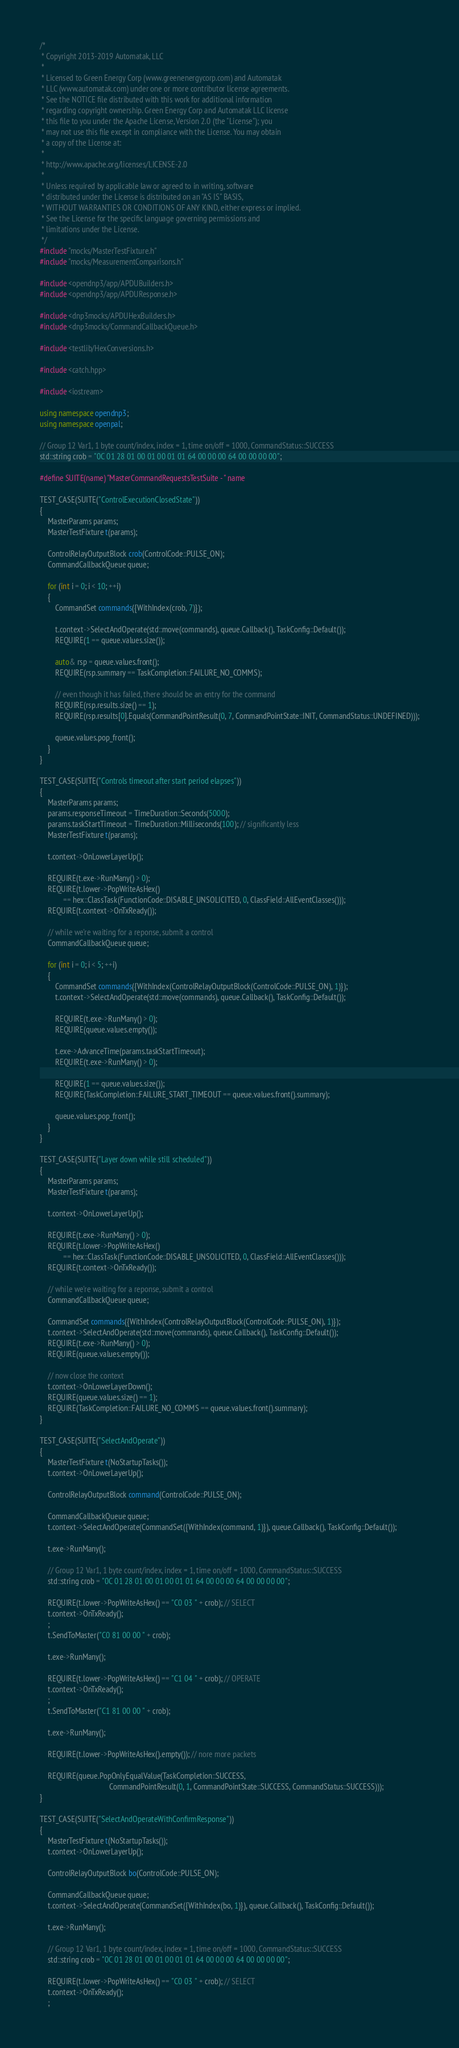<code> <loc_0><loc_0><loc_500><loc_500><_C++_>/*
 * Copyright 2013-2019 Automatak, LLC
 *
 * Licensed to Green Energy Corp (www.greenenergycorp.com) and Automatak
 * LLC (www.automatak.com) under one or more contributor license agreements.
 * See the NOTICE file distributed with this work for additional information
 * regarding copyright ownership. Green Energy Corp and Automatak LLC license
 * this file to you under the Apache License, Version 2.0 (the "License"); you
 * may not use this file except in compliance with the License. You may obtain
 * a copy of the License at:
 *
 * http://www.apache.org/licenses/LICENSE-2.0
 *
 * Unless required by applicable law or agreed to in writing, software
 * distributed under the License is distributed on an "AS IS" BASIS,
 * WITHOUT WARRANTIES OR CONDITIONS OF ANY KIND, either express or implied.
 * See the License for the specific language governing permissions and
 * limitations under the License.
 */
#include "mocks/MasterTestFixture.h"
#include "mocks/MeasurementComparisons.h"

#include <opendnp3/app/APDUBuilders.h>
#include <opendnp3/app/APDUResponse.h>

#include <dnp3mocks/APDUHexBuilders.h>
#include <dnp3mocks/CommandCallbackQueue.h>

#include <testlib/HexConversions.h>

#include <catch.hpp>

#include <iostream>

using namespace opendnp3;
using namespace openpal;

// Group 12 Var1, 1 byte count/index, index = 1, time on/off = 1000, CommandStatus::SUCCESS
std::string crob = "0C 01 28 01 00 01 00 01 01 64 00 00 00 64 00 00 00 00";

#define SUITE(name) "MasterCommandRequestsTestSuite - " name

TEST_CASE(SUITE("ControlExecutionClosedState"))
{
    MasterParams params;
    MasterTestFixture t(params);

    ControlRelayOutputBlock crob(ControlCode::PULSE_ON);
    CommandCallbackQueue queue;

    for (int i = 0; i < 10; ++i)
    {
        CommandSet commands({WithIndex(crob, 7)});

        t.context->SelectAndOperate(std::move(commands), queue.Callback(), TaskConfig::Default());
        REQUIRE(1 == queue.values.size());

        auto& rsp = queue.values.front();
        REQUIRE(rsp.summary == TaskCompletion::FAILURE_NO_COMMS);

        // even though it has failed, there should be an entry for the command
        REQUIRE(rsp.results.size() == 1);
        REQUIRE(rsp.results[0].Equals(CommandPointResult(0, 7, CommandPointState::INIT, CommandStatus::UNDEFINED)));

        queue.values.pop_front();
    }
}

TEST_CASE(SUITE("Controls timeout after start period elapses"))
{
    MasterParams params;
    params.responseTimeout = TimeDuration::Seconds(5000);
    params.taskStartTimeout = TimeDuration::Milliseconds(100); // significantly less
    MasterTestFixture t(params);

    t.context->OnLowerLayerUp();

    REQUIRE(t.exe->RunMany() > 0);
    REQUIRE(t.lower->PopWriteAsHex()
            == hex::ClassTask(FunctionCode::DISABLE_UNSOLICITED, 0, ClassField::AllEventClasses()));
    REQUIRE(t.context->OnTxReady());

    // while we're waiting for a reponse, submit a control
    CommandCallbackQueue queue;

    for (int i = 0; i < 5; ++i)
    {
        CommandSet commands({WithIndex(ControlRelayOutputBlock(ControlCode::PULSE_ON), 1)});
        t.context->SelectAndOperate(std::move(commands), queue.Callback(), TaskConfig::Default());

        REQUIRE(t.exe->RunMany() > 0);
        REQUIRE(queue.values.empty());

        t.exe->AdvanceTime(params.taskStartTimeout);
        REQUIRE(t.exe->RunMany() > 0);

        REQUIRE(1 == queue.values.size());
        REQUIRE(TaskCompletion::FAILURE_START_TIMEOUT == queue.values.front().summary);

        queue.values.pop_front();
    }
}

TEST_CASE(SUITE("Layer down while still scheduled"))
{
    MasterParams params;
    MasterTestFixture t(params);

    t.context->OnLowerLayerUp();

    REQUIRE(t.exe->RunMany() > 0);
    REQUIRE(t.lower->PopWriteAsHex()
            == hex::ClassTask(FunctionCode::DISABLE_UNSOLICITED, 0, ClassField::AllEventClasses()));
    REQUIRE(t.context->OnTxReady());

    // while we're waiting for a reponse, submit a control
    CommandCallbackQueue queue;

    CommandSet commands({WithIndex(ControlRelayOutputBlock(ControlCode::PULSE_ON), 1)});
    t.context->SelectAndOperate(std::move(commands), queue.Callback(), TaskConfig::Default());
    REQUIRE(t.exe->RunMany() > 0);
    REQUIRE(queue.values.empty());

    // now close the context
    t.context->OnLowerLayerDown();
    REQUIRE(queue.values.size() == 1);
    REQUIRE(TaskCompletion::FAILURE_NO_COMMS == queue.values.front().summary);
}

TEST_CASE(SUITE("SelectAndOperate"))
{
    MasterTestFixture t(NoStartupTasks());
    t.context->OnLowerLayerUp();

    ControlRelayOutputBlock command(ControlCode::PULSE_ON);

    CommandCallbackQueue queue;
    t.context->SelectAndOperate(CommandSet({WithIndex(command, 1)}), queue.Callback(), TaskConfig::Default());

    t.exe->RunMany();

    // Group 12 Var1, 1 byte count/index, index = 1, time on/off = 1000, CommandStatus::SUCCESS
    std::string crob = "0C 01 28 01 00 01 00 01 01 64 00 00 00 64 00 00 00 00";

    REQUIRE(t.lower->PopWriteAsHex() == "C0 03 " + crob); // SELECT
    t.context->OnTxReady();
    ;
    t.SendToMaster("C0 81 00 00 " + crob);

    t.exe->RunMany();

    REQUIRE(t.lower->PopWriteAsHex() == "C1 04 " + crob); // OPERATE
    t.context->OnTxReady();
    ;
    t.SendToMaster("C1 81 00 00 " + crob);

    t.exe->RunMany();

    REQUIRE(t.lower->PopWriteAsHex().empty()); // nore more packets

    REQUIRE(queue.PopOnlyEqualValue(TaskCompletion::SUCCESS,
                                    CommandPointResult(0, 1, CommandPointState::SUCCESS, CommandStatus::SUCCESS)));
}

TEST_CASE(SUITE("SelectAndOperateWithConfirmResponse"))
{
    MasterTestFixture t(NoStartupTasks());
    t.context->OnLowerLayerUp();

    ControlRelayOutputBlock bo(ControlCode::PULSE_ON);

    CommandCallbackQueue queue;
    t.context->SelectAndOperate(CommandSet({WithIndex(bo, 1)}), queue.Callback(), TaskConfig::Default());

    t.exe->RunMany();

    // Group 12 Var1, 1 byte count/index, index = 1, time on/off = 1000, CommandStatus::SUCCESS
    std::string crob = "0C 01 28 01 00 01 00 01 01 64 00 00 00 64 00 00 00 00";

    REQUIRE(t.lower->PopWriteAsHex() == "C0 03 " + crob); // SELECT
    t.context->OnTxReady();
    ;</code> 